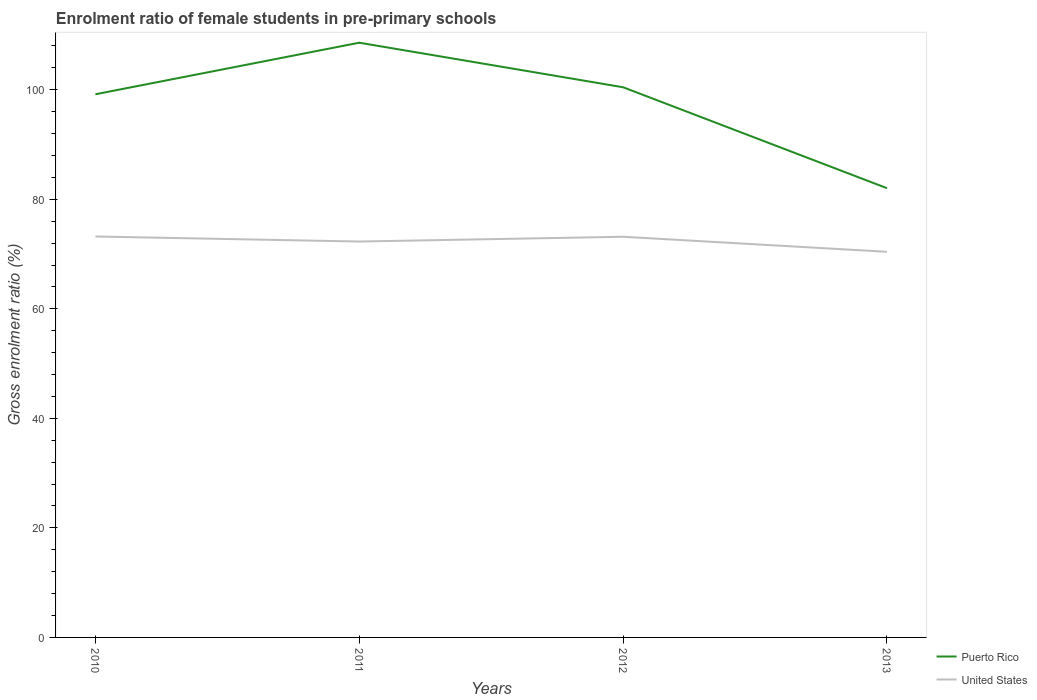Does the line corresponding to United States intersect with the line corresponding to Puerto Rico?
Provide a succinct answer. No. Is the number of lines equal to the number of legend labels?
Provide a short and direct response. Yes. Across all years, what is the maximum enrolment ratio of female students in pre-primary schools in United States?
Your answer should be very brief. 70.41. What is the total enrolment ratio of female students in pre-primary schools in Puerto Rico in the graph?
Your answer should be compact. -9.41. What is the difference between the highest and the second highest enrolment ratio of female students in pre-primary schools in United States?
Ensure brevity in your answer.  2.79. How many lines are there?
Your answer should be compact. 2. How many years are there in the graph?
Your answer should be compact. 4. What is the difference between two consecutive major ticks on the Y-axis?
Offer a very short reply. 20. Are the values on the major ticks of Y-axis written in scientific E-notation?
Keep it short and to the point. No. Where does the legend appear in the graph?
Keep it short and to the point. Bottom right. How are the legend labels stacked?
Ensure brevity in your answer.  Vertical. What is the title of the graph?
Your answer should be compact. Enrolment ratio of female students in pre-primary schools. Does "Zimbabwe" appear as one of the legend labels in the graph?
Ensure brevity in your answer.  No. What is the label or title of the X-axis?
Your answer should be very brief. Years. What is the label or title of the Y-axis?
Ensure brevity in your answer.  Gross enrolment ratio (%). What is the Gross enrolment ratio (%) in Puerto Rico in 2010?
Offer a very short reply. 99.18. What is the Gross enrolment ratio (%) in United States in 2010?
Your response must be concise. 73.2. What is the Gross enrolment ratio (%) in Puerto Rico in 2011?
Offer a very short reply. 108.59. What is the Gross enrolment ratio (%) of United States in 2011?
Provide a short and direct response. 72.28. What is the Gross enrolment ratio (%) in Puerto Rico in 2012?
Offer a very short reply. 100.45. What is the Gross enrolment ratio (%) of United States in 2012?
Your response must be concise. 73.16. What is the Gross enrolment ratio (%) of Puerto Rico in 2013?
Offer a very short reply. 82.03. What is the Gross enrolment ratio (%) of United States in 2013?
Give a very brief answer. 70.41. Across all years, what is the maximum Gross enrolment ratio (%) of Puerto Rico?
Offer a terse response. 108.59. Across all years, what is the maximum Gross enrolment ratio (%) in United States?
Your response must be concise. 73.2. Across all years, what is the minimum Gross enrolment ratio (%) in Puerto Rico?
Make the answer very short. 82.03. Across all years, what is the minimum Gross enrolment ratio (%) of United States?
Give a very brief answer. 70.41. What is the total Gross enrolment ratio (%) of Puerto Rico in the graph?
Your response must be concise. 390.24. What is the total Gross enrolment ratio (%) in United States in the graph?
Make the answer very short. 289.06. What is the difference between the Gross enrolment ratio (%) of Puerto Rico in 2010 and that in 2011?
Offer a very short reply. -9.41. What is the difference between the Gross enrolment ratio (%) in United States in 2010 and that in 2011?
Provide a succinct answer. 0.92. What is the difference between the Gross enrolment ratio (%) of Puerto Rico in 2010 and that in 2012?
Keep it short and to the point. -1.28. What is the difference between the Gross enrolment ratio (%) of United States in 2010 and that in 2012?
Provide a short and direct response. 0.05. What is the difference between the Gross enrolment ratio (%) in Puerto Rico in 2010 and that in 2013?
Provide a succinct answer. 17.15. What is the difference between the Gross enrolment ratio (%) of United States in 2010 and that in 2013?
Offer a terse response. 2.79. What is the difference between the Gross enrolment ratio (%) of Puerto Rico in 2011 and that in 2012?
Your answer should be very brief. 8.14. What is the difference between the Gross enrolment ratio (%) in United States in 2011 and that in 2012?
Ensure brevity in your answer.  -0.87. What is the difference between the Gross enrolment ratio (%) of Puerto Rico in 2011 and that in 2013?
Keep it short and to the point. 26.56. What is the difference between the Gross enrolment ratio (%) of United States in 2011 and that in 2013?
Provide a succinct answer. 1.87. What is the difference between the Gross enrolment ratio (%) of Puerto Rico in 2012 and that in 2013?
Your answer should be very brief. 18.43. What is the difference between the Gross enrolment ratio (%) of United States in 2012 and that in 2013?
Your answer should be very brief. 2.75. What is the difference between the Gross enrolment ratio (%) of Puerto Rico in 2010 and the Gross enrolment ratio (%) of United States in 2011?
Provide a succinct answer. 26.89. What is the difference between the Gross enrolment ratio (%) of Puerto Rico in 2010 and the Gross enrolment ratio (%) of United States in 2012?
Offer a terse response. 26.02. What is the difference between the Gross enrolment ratio (%) of Puerto Rico in 2010 and the Gross enrolment ratio (%) of United States in 2013?
Your answer should be compact. 28.76. What is the difference between the Gross enrolment ratio (%) in Puerto Rico in 2011 and the Gross enrolment ratio (%) in United States in 2012?
Keep it short and to the point. 35.43. What is the difference between the Gross enrolment ratio (%) of Puerto Rico in 2011 and the Gross enrolment ratio (%) of United States in 2013?
Provide a succinct answer. 38.18. What is the difference between the Gross enrolment ratio (%) in Puerto Rico in 2012 and the Gross enrolment ratio (%) in United States in 2013?
Ensure brevity in your answer.  30.04. What is the average Gross enrolment ratio (%) in Puerto Rico per year?
Provide a short and direct response. 97.56. What is the average Gross enrolment ratio (%) of United States per year?
Provide a short and direct response. 72.26. In the year 2010, what is the difference between the Gross enrolment ratio (%) in Puerto Rico and Gross enrolment ratio (%) in United States?
Provide a short and direct response. 25.97. In the year 2011, what is the difference between the Gross enrolment ratio (%) of Puerto Rico and Gross enrolment ratio (%) of United States?
Keep it short and to the point. 36.3. In the year 2012, what is the difference between the Gross enrolment ratio (%) of Puerto Rico and Gross enrolment ratio (%) of United States?
Your answer should be very brief. 27.3. In the year 2013, what is the difference between the Gross enrolment ratio (%) of Puerto Rico and Gross enrolment ratio (%) of United States?
Ensure brevity in your answer.  11.61. What is the ratio of the Gross enrolment ratio (%) of Puerto Rico in 2010 to that in 2011?
Your answer should be compact. 0.91. What is the ratio of the Gross enrolment ratio (%) of United States in 2010 to that in 2011?
Your answer should be very brief. 1.01. What is the ratio of the Gross enrolment ratio (%) in Puerto Rico in 2010 to that in 2012?
Your response must be concise. 0.99. What is the ratio of the Gross enrolment ratio (%) in Puerto Rico in 2010 to that in 2013?
Keep it short and to the point. 1.21. What is the ratio of the Gross enrolment ratio (%) of United States in 2010 to that in 2013?
Your answer should be very brief. 1.04. What is the ratio of the Gross enrolment ratio (%) of Puerto Rico in 2011 to that in 2012?
Keep it short and to the point. 1.08. What is the ratio of the Gross enrolment ratio (%) in United States in 2011 to that in 2012?
Make the answer very short. 0.99. What is the ratio of the Gross enrolment ratio (%) of Puerto Rico in 2011 to that in 2013?
Give a very brief answer. 1.32. What is the ratio of the Gross enrolment ratio (%) of United States in 2011 to that in 2013?
Offer a terse response. 1.03. What is the ratio of the Gross enrolment ratio (%) in Puerto Rico in 2012 to that in 2013?
Make the answer very short. 1.22. What is the ratio of the Gross enrolment ratio (%) of United States in 2012 to that in 2013?
Your answer should be very brief. 1.04. What is the difference between the highest and the second highest Gross enrolment ratio (%) in Puerto Rico?
Provide a short and direct response. 8.14. What is the difference between the highest and the second highest Gross enrolment ratio (%) of United States?
Your response must be concise. 0.05. What is the difference between the highest and the lowest Gross enrolment ratio (%) of Puerto Rico?
Keep it short and to the point. 26.56. What is the difference between the highest and the lowest Gross enrolment ratio (%) in United States?
Ensure brevity in your answer.  2.79. 